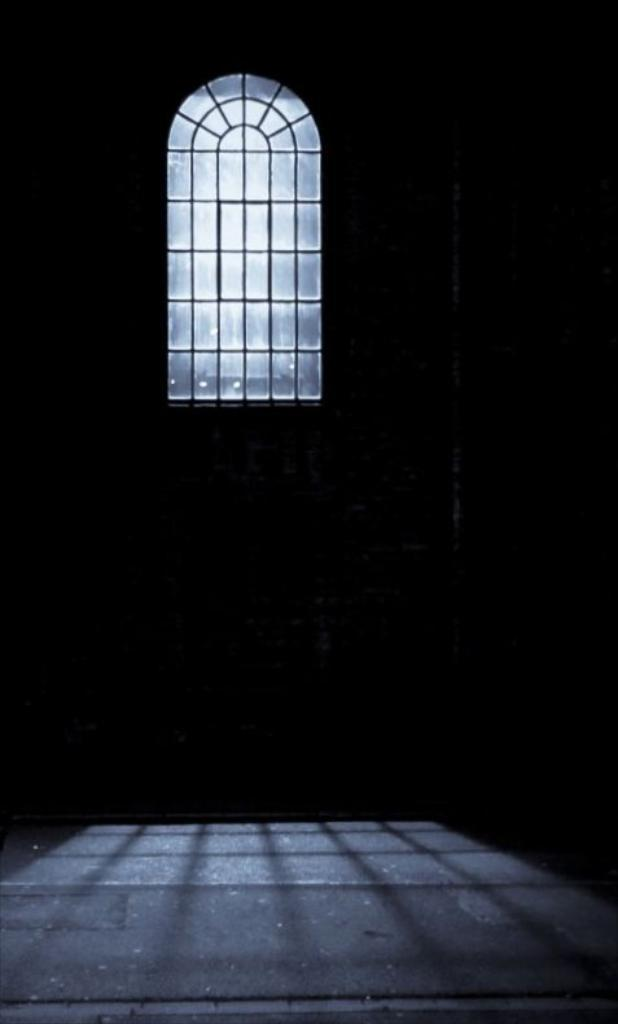What part of a room is visible in the image? The image shows the inner part of a room. Can you describe any specific features of the room? Unfortunately, the provided facts do not mention any specific features of the room. What is visible in the background of the image? There is a glass window visible in the background of the image. Can you tell me how many actors are visible in the image? There are no actors present in the image. What type of trail can be seen leading up to the room in the image? There is no trail visible in the image. 